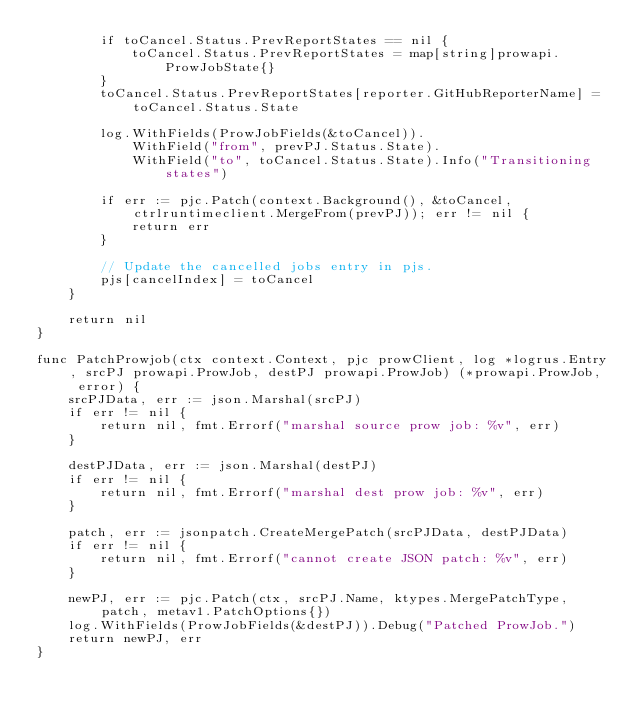Convert code to text. <code><loc_0><loc_0><loc_500><loc_500><_Go_>		if toCancel.Status.PrevReportStates == nil {
			toCancel.Status.PrevReportStates = map[string]prowapi.ProwJobState{}
		}
		toCancel.Status.PrevReportStates[reporter.GitHubReporterName] = toCancel.Status.State

		log.WithFields(ProwJobFields(&toCancel)).
			WithField("from", prevPJ.Status.State).
			WithField("to", toCancel.Status.State).Info("Transitioning states")

		if err := pjc.Patch(context.Background(), &toCancel, ctrlruntimeclient.MergeFrom(prevPJ)); err != nil {
			return err
		}

		// Update the cancelled jobs entry in pjs.
		pjs[cancelIndex] = toCancel
	}

	return nil
}

func PatchProwjob(ctx context.Context, pjc prowClient, log *logrus.Entry, srcPJ prowapi.ProwJob, destPJ prowapi.ProwJob) (*prowapi.ProwJob, error) {
	srcPJData, err := json.Marshal(srcPJ)
	if err != nil {
		return nil, fmt.Errorf("marshal source prow job: %v", err)
	}

	destPJData, err := json.Marshal(destPJ)
	if err != nil {
		return nil, fmt.Errorf("marshal dest prow job: %v", err)
	}

	patch, err := jsonpatch.CreateMergePatch(srcPJData, destPJData)
	if err != nil {
		return nil, fmt.Errorf("cannot create JSON patch: %v", err)
	}

	newPJ, err := pjc.Patch(ctx, srcPJ.Name, ktypes.MergePatchType, patch, metav1.PatchOptions{})
	log.WithFields(ProwJobFields(&destPJ)).Debug("Patched ProwJob.")
	return newPJ, err
}
</code> 